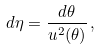Convert formula to latex. <formula><loc_0><loc_0><loc_500><loc_500>d \eta = \frac { d \theta } { u ^ { 2 } ( \theta ) } \, ,</formula> 